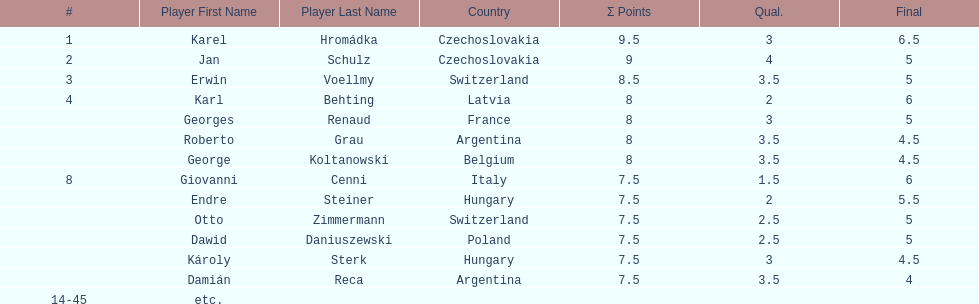Jan schulz is ranked immediately below which player? Karel Hromádka. 